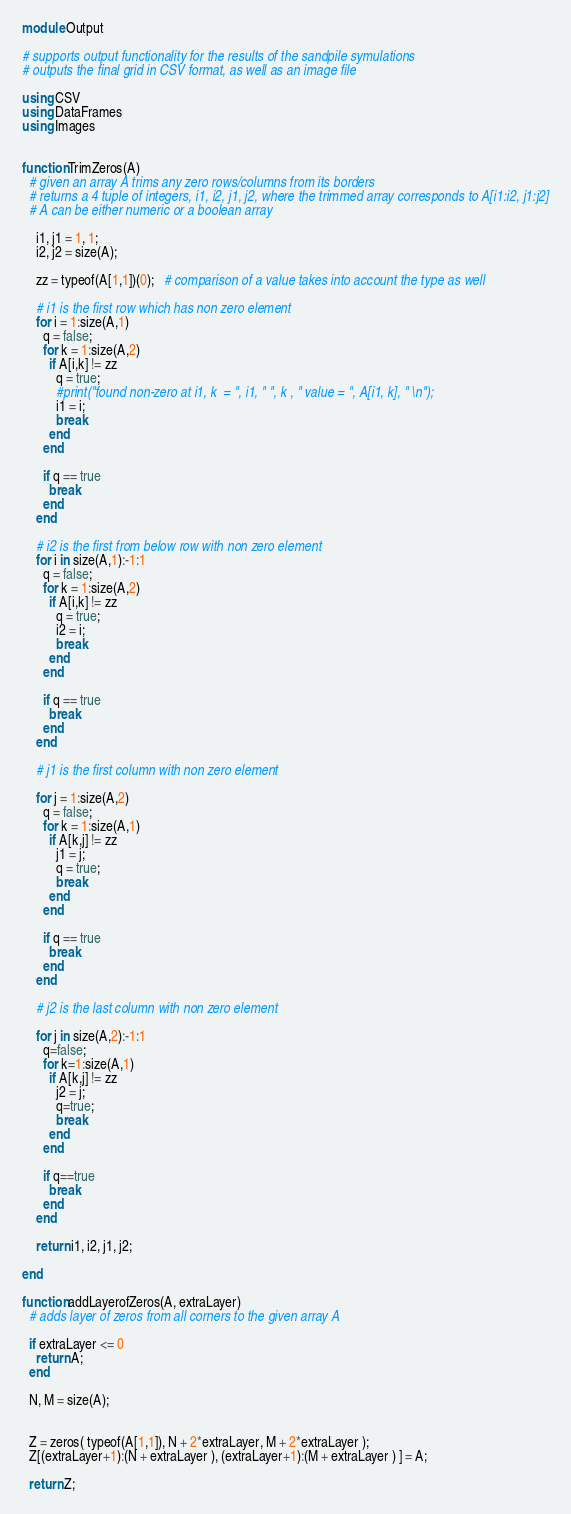Convert code to text. <code><loc_0><loc_0><loc_500><loc_500><_Julia_>module Output

# supports output functionality for the results of the sandpile symulations
# outputs the final grid in CSV format, as well as an image file

using CSV
using DataFrames
using Images


function TrimZeros(A)
  # given an array A trims any zero rows/columns from its borders
  # returns a 4 tuple of integers, i1, i2, j1, j2, where the trimmed array corresponds to A[i1:i2, j1:j2]
  # A can be either numeric or a boolean array

    i1, j1 = 1, 1;
    i2, j2 = size(A);

    zz = typeof(A[1,1])(0);   # comparison of a value takes into account the type as well

    # i1 is the first row which has non zero element
    for i = 1:size(A,1)
      q = false;
      for k = 1:size(A,2)
        if A[i,k] != zz
          q = true;
          #print("found non-zero at i1, k  = ", i1, " ", k , " value = ", A[i1, k], " \n");
          i1 = i;
          break
        end
      end

      if q == true
        break
      end
    end

    # i2 is the first from below row with non zero element
    for i in size(A,1):-1:1
      q = false;
      for k = 1:size(A,2)
        if A[i,k] != zz
          q = true;
          i2 = i;
          break
        end
      end

      if q == true
        break
      end
    end

    # j1 is the first column with non zero element

    for j = 1:size(A,2)
      q = false;
      for k = 1:size(A,1)
        if A[k,j] != zz
          j1 = j;
          q = true;
          break
        end
      end

      if q == true
        break
      end
    end

    # j2 is the last column with non zero element

    for j in size(A,2):-1:1
      q=false;
      for k=1:size(A,1)
        if A[k,j] != zz
          j2 = j;
          q=true;
          break
        end
      end

      if q==true
        break
      end
    end

    return i1, i2, j1, j2;

end

function addLayerofZeros(A, extraLayer)
  # adds layer of zeros from all corners to the given array A

  if extraLayer <= 0
    return A;
  end

  N, M = size(A);


  Z = zeros( typeof(A[1,1]), N + 2*extraLayer, M + 2*extraLayer );
  Z[(extraLayer+1):(N + extraLayer ), (extraLayer+1):(M + extraLayer ) ] = A;

  return Z;
</code> 